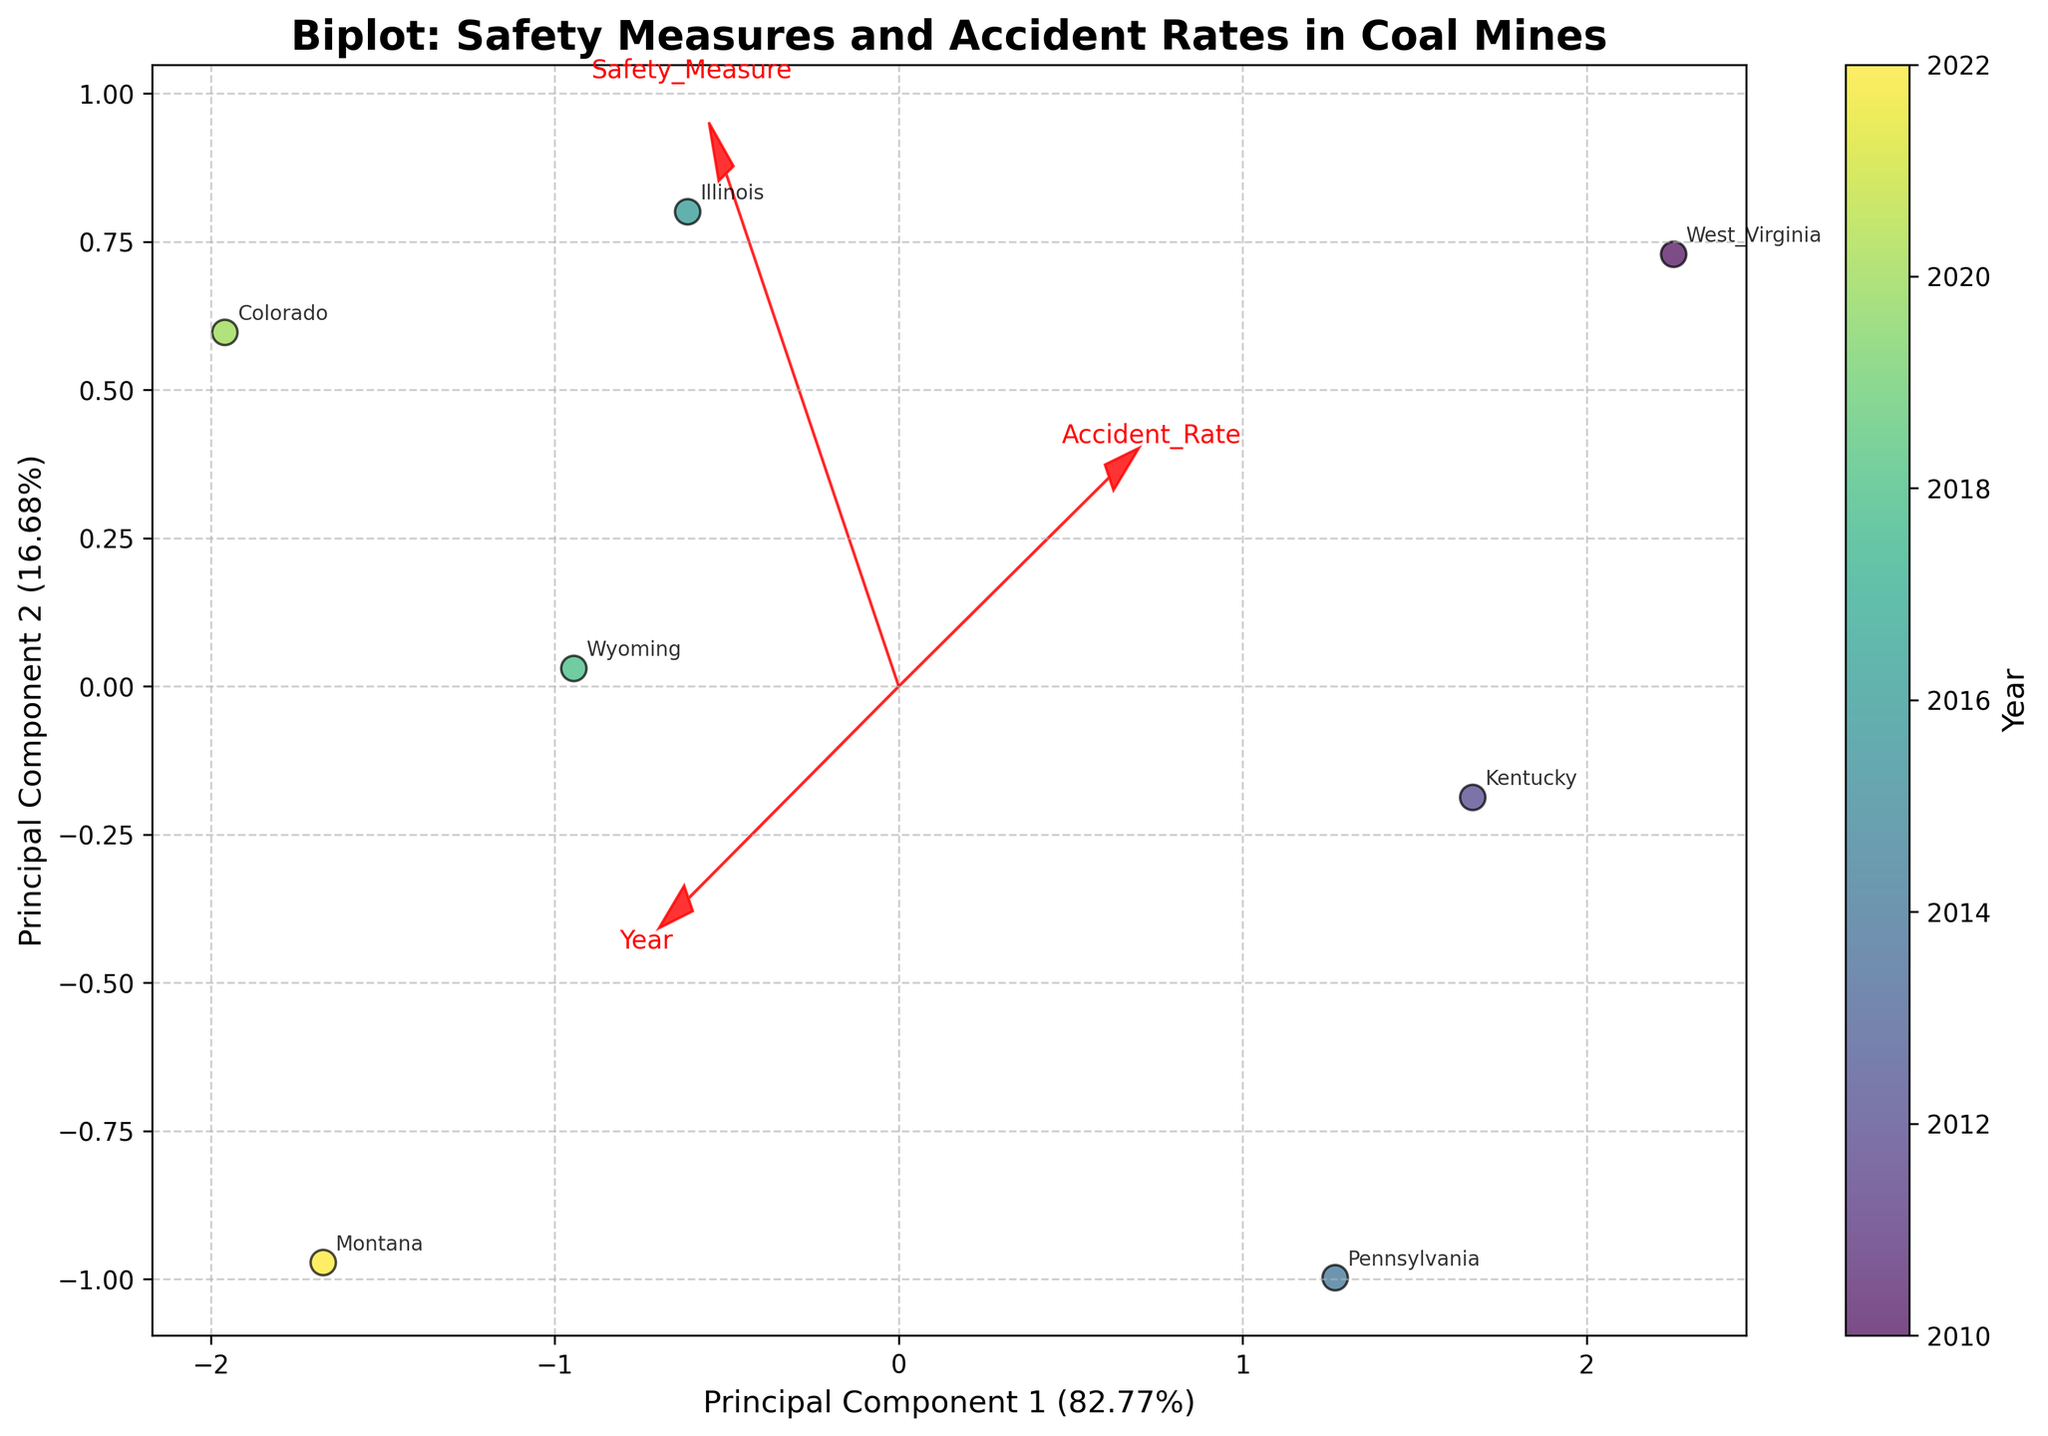1. What is the title of the figure? The title can be found at the top of the figure. It usually summarizes the main topic or intent of the visualization. Here, it is "Biplot: Safety Measures and Accident Rates in Coal Mines".
Answer: Biplot: Safety Measures and Accident Rates in Coal Mines 2. How many data points are in the biplot? The data points correspond to the number of entries in the coal mine data. Each data point is represented by a scatter marker on the plot. Counting the markers or annotations for mine locations provides the total number. Here, there are 7 data points.
Answer: 7 3. Which safety measure is associated with the lowest accident rate and what year was it implemented? The figure shows the relationship between safety measures and accident rates over time. By identifying the lowest point on the accident rate axis and checking the corresponding annotation and color on the color scale, we see that "Personal Protective Equipment" was associated with the lowest accident rate in the year 2022.
Answer: Personal Protective Equipment, 2022 4. How does the accident rate change over time based on the biplot? By examining the scatter points colored by year, we can observe a trend. The scatter points move towards lower accident rates as the years progress. This shows a general downward trend in accident rates over time.
Answer: Decreases over time 5. What principal components are used on the X and Y axes, and what is their explained variance? The axes are labeled with the principal components and their explained variances. From the labels, we identify Principal Component 1 on the X-axis and Principal Component 2 on the Y-axis, with explained variances of 74% and 20%, respectively.
Answer: Principal Component 1 (74%), Principal Component 2 (20%) 6. Which mine location has the highest accident rate and what safety measure was implemented there? The highest accident rate corresponds to the highest point on the accident rate axis. The annotation for this point shows it in West Virginia, with the safety measure being "Methane Detection Systems".
Answer: West Virginia, Methane Detection Systems 7. Are the vectors for "Safety Measure" and "Year" positively or negatively correlated? The biplot contains feature vectors represented by arrows. The vector directions indicate correlations. If the arrows for "Safety Measure" and "Year" point in similar directions, they are positively correlated. Here, they both point in roughly the same direction.
Answer: Positively correlated 8. Compare the implementation years of "Improved Ventilation" and "Rock Dust Application" with respect to accident rates. Which had a more significant reduction in accident rates? Looking at the years and accident rates, we see "Improved Ventilation" (2012) and "Rock Dust Application" (2016). The reduction in accident rates from 12.5 to 10.2 (for Improved Ventilation) is 2.3, while from 8.7 to 7.3 (for Rock Dust Application) is 1.4. Therefore, Improved Ventilation had a more significant reduction.
Answer: Improved Ventilation 9. What is the general direction of the PC1 axis and which variables does it primarily involve? The direction of the PC1 axis can be determined by observing the arrows and their length. PC1 captures most variance and is aligned with the variables showing significant change. Here, it involves "Safety Measure" and "Year".
Answer: Safety Measure, Year 10. How does the mine location in Colorado compare to Wyoming in terms of accident rate and safety measure? By locating the points for Colorado and Wyoming, we can compare their positions. Colorado had a lower accident rate and implemented "Roof Support Systems" in 2020, while Wyoming implemented "Proximity Detection Devices" in 2018 with a slightly higher accident rate.
Answer: Colorado: Lower rate, Roof Support Systems; Wyoming: Higher rate, Proximity Detection Devices 